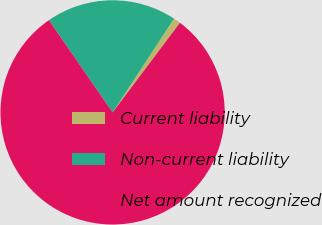<chart> <loc_0><loc_0><loc_500><loc_500><pie_chart><fcel>Current liability<fcel>Non-current liability<fcel>Net amount recognized<nl><fcel>1.03%<fcel>18.85%<fcel>80.13%<nl></chart> 